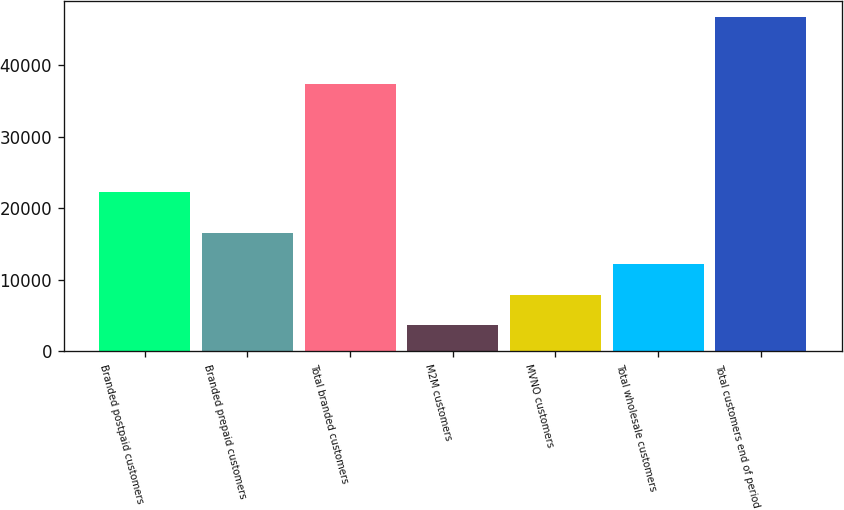Convert chart to OTSL. <chart><loc_0><loc_0><loc_500><loc_500><bar_chart><fcel>Branded postpaid customers<fcel>Branded prepaid customers<fcel>Total branded customers<fcel>M2M customers<fcel>MVNO customers<fcel>Total wholesale customers<fcel>Total customers end of period<nl><fcel>22299<fcel>16526.6<fcel>37371<fcel>3602<fcel>7910.2<fcel>12218.4<fcel>46684<nl></chart> 